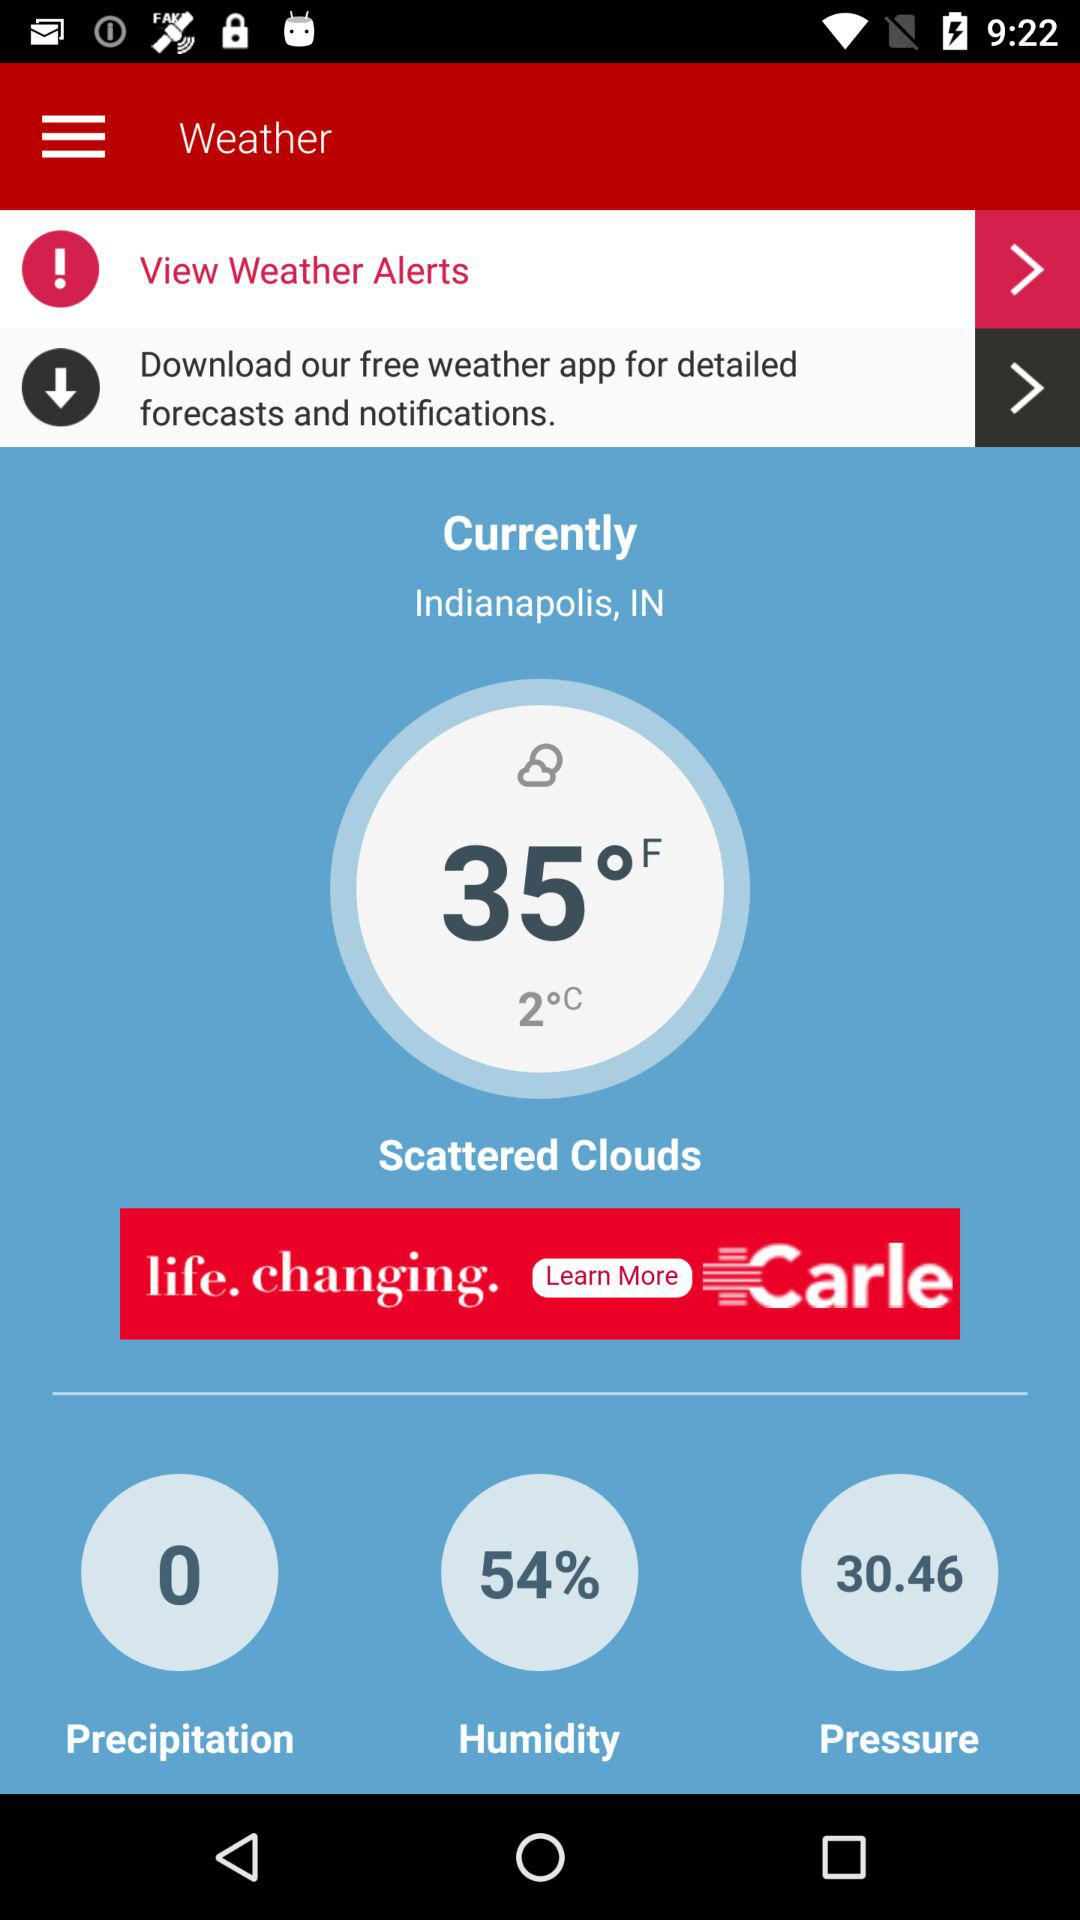What is the pressure given? The pressure is 30.46. 